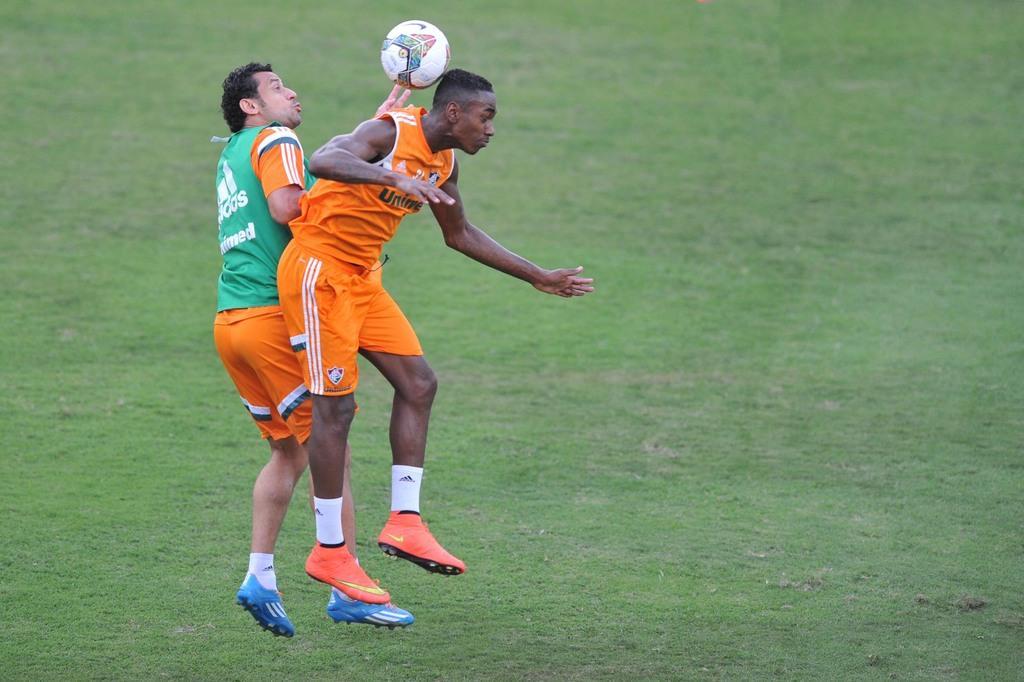Describe this image in one or two sentences. In this picture there is a man who is wearing orange dress. Here we can see another man who is wearing green t-shirt, short and blue shoes. Both of them jumping to hit the football. At the bottom we can see the grass. In the background we can see the football ground. 